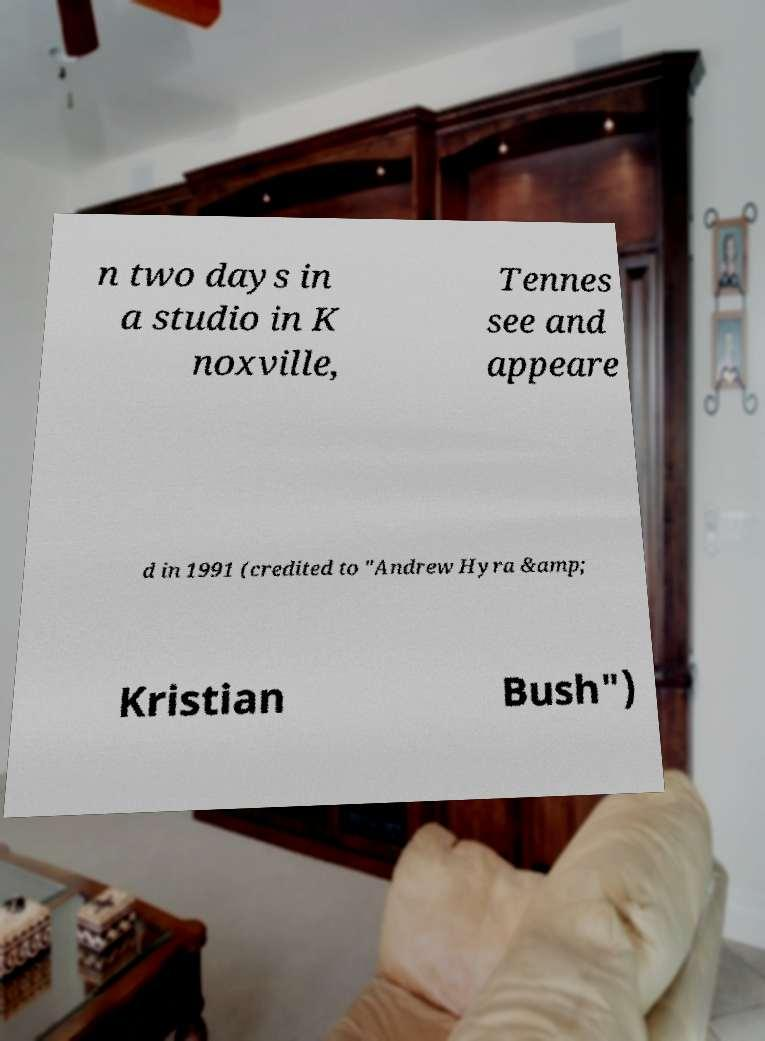For documentation purposes, I need the text within this image transcribed. Could you provide that? n two days in a studio in K noxville, Tennes see and appeare d in 1991 (credited to "Andrew Hyra &amp; Kristian Bush") 